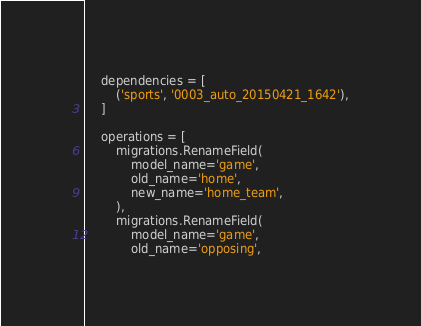Convert code to text. <code><loc_0><loc_0><loc_500><loc_500><_Python_>    dependencies = [
        ('sports', '0003_auto_20150421_1642'),
    ]

    operations = [
        migrations.RenameField(
            model_name='game',
            old_name='home',
            new_name='home_team',
        ),
        migrations.RenameField(
            model_name='game',
            old_name='opposing',</code> 